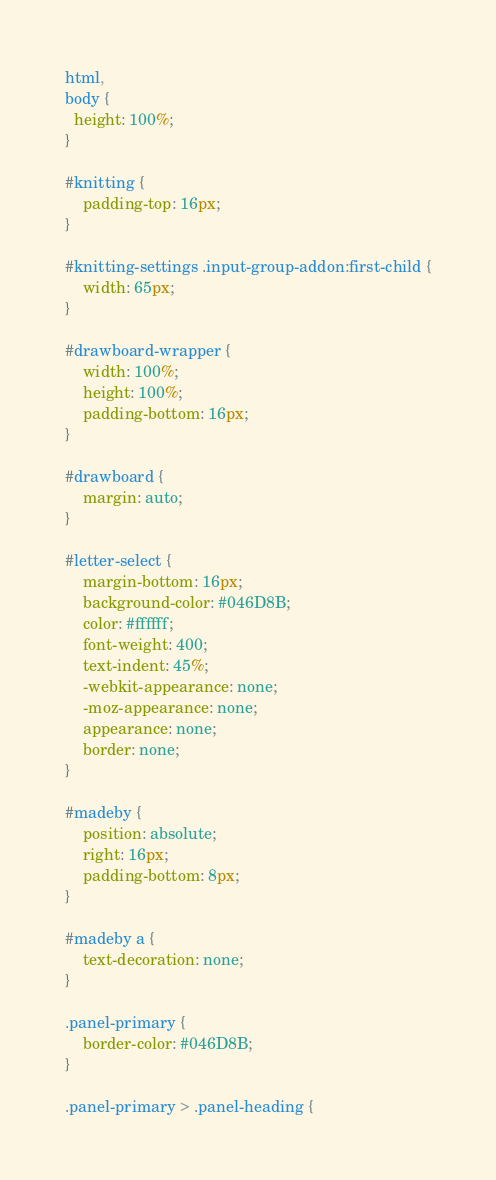<code> <loc_0><loc_0><loc_500><loc_500><_CSS_>html,
body {
  height: 100%;
}

#knitting {
    padding-top: 16px;
}

#knitting-settings .input-group-addon:first-child {
    width: 65px;
}

#drawboard-wrapper {
    width: 100%;
    height: 100%;
    padding-bottom: 16px;
}

#drawboard {
    margin: auto;
}

#letter-select {
    margin-bottom: 16px;
    background-color: #046D8B;
    color: #ffffff;
    font-weight: 400;
    text-indent: 45%;
    -webkit-appearance: none;
    -moz-appearance: none;
    appearance: none;
    border: none;
}

#madeby {
    position: absolute;
    right: 16px;
    padding-bottom: 8px;
}

#madeby a {
    text-decoration: none;
}

.panel-primary {
    border-color: #046D8B;
}

.panel-primary > .panel-heading {</code> 